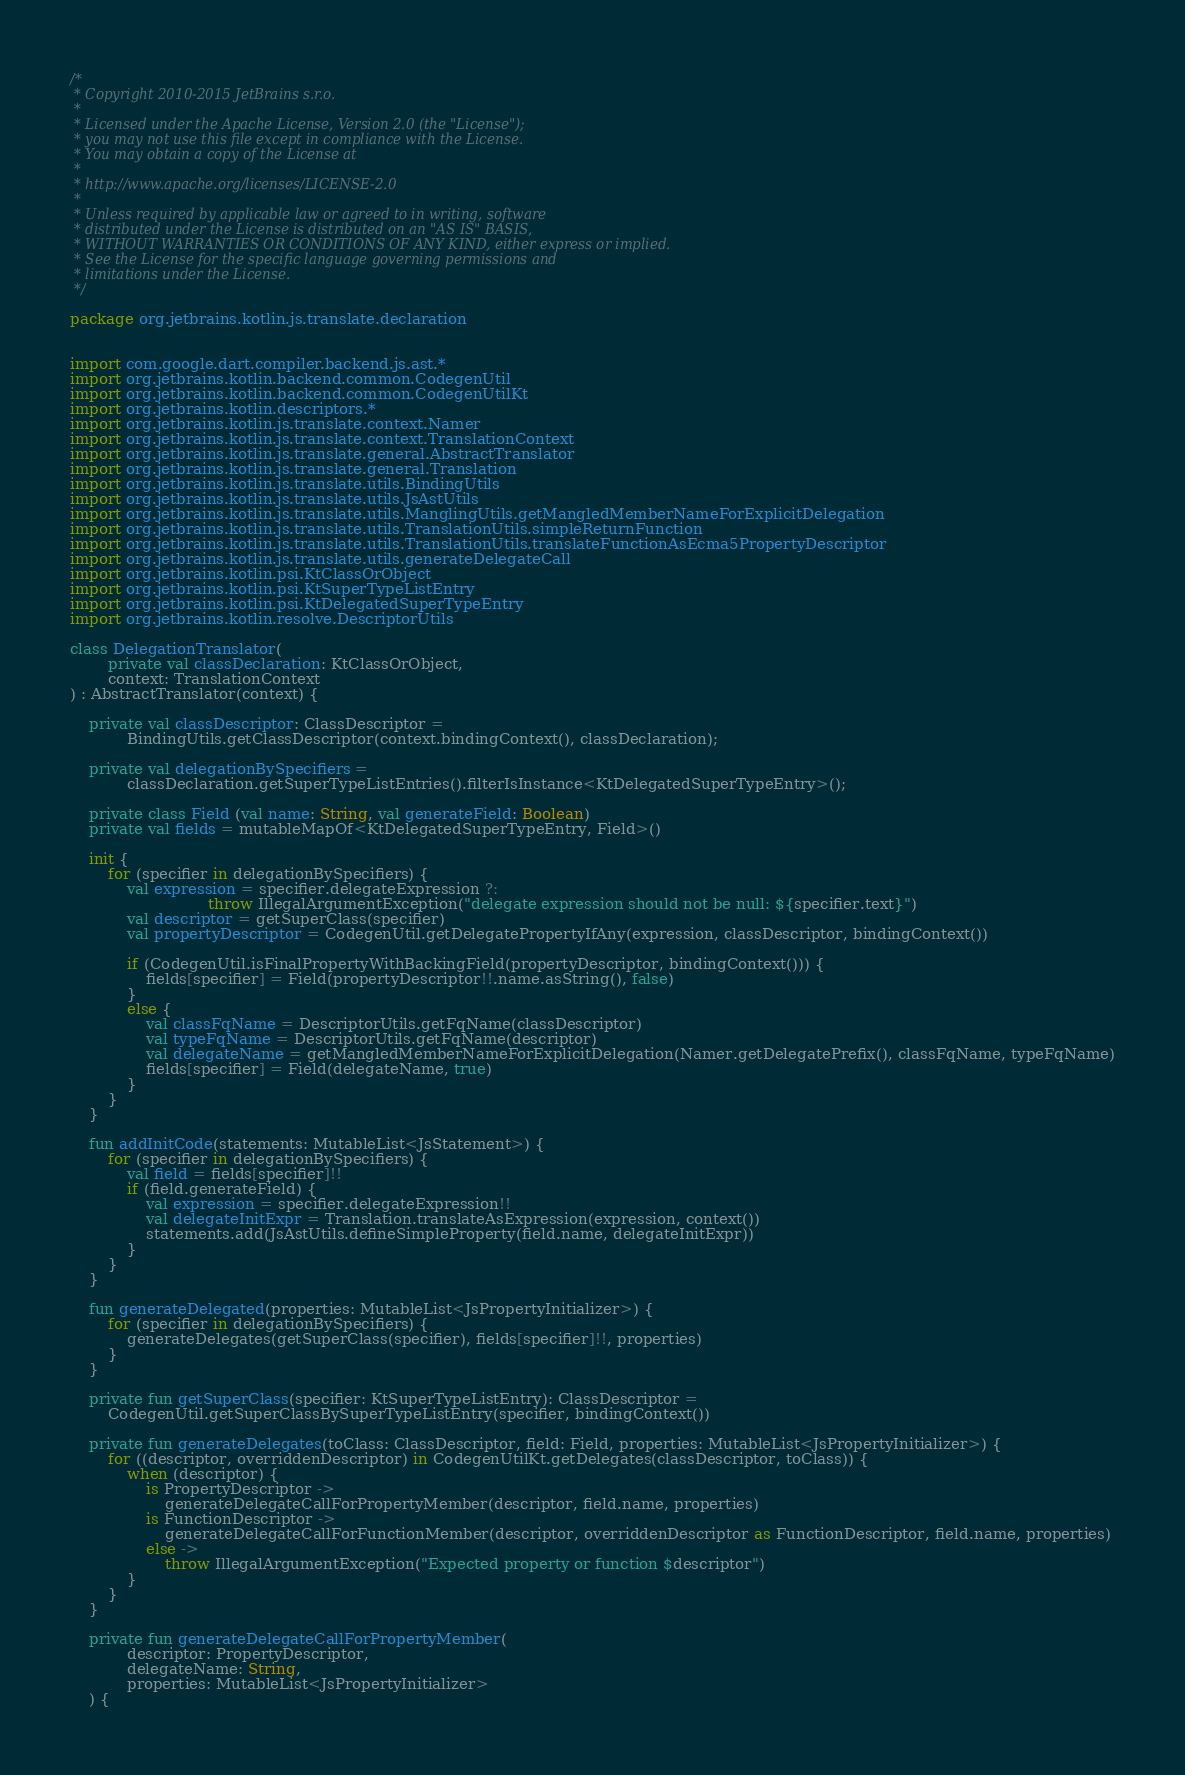<code> <loc_0><loc_0><loc_500><loc_500><_Kotlin_>/*
 * Copyright 2010-2015 JetBrains s.r.o.
 *
 * Licensed under the Apache License, Version 2.0 (the "License");
 * you may not use this file except in compliance with the License.
 * You may obtain a copy of the License at
 *
 * http://www.apache.org/licenses/LICENSE-2.0
 *
 * Unless required by applicable law or agreed to in writing, software
 * distributed under the License is distributed on an "AS IS" BASIS,
 * WITHOUT WARRANTIES OR CONDITIONS OF ANY KIND, either express or implied.
 * See the License for the specific language governing permissions and
 * limitations under the License.
 */

package org.jetbrains.kotlin.js.translate.declaration


import com.google.dart.compiler.backend.js.ast.*
import org.jetbrains.kotlin.backend.common.CodegenUtil
import org.jetbrains.kotlin.backend.common.CodegenUtilKt
import org.jetbrains.kotlin.descriptors.*
import org.jetbrains.kotlin.js.translate.context.Namer
import org.jetbrains.kotlin.js.translate.context.TranslationContext
import org.jetbrains.kotlin.js.translate.general.AbstractTranslator
import org.jetbrains.kotlin.js.translate.general.Translation
import org.jetbrains.kotlin.js.translate.utils.BindingUtils
import org.jetbrains.kotlin.js.translate.utils.JsAstUtils
import org.jetbrains.kotlin.js.translate.utils.ManglingUtils.getMangledMemberNameForExplicitDelegation
import org.jetbrains.kotlin.js.translate.utils.TranslationUtils.simpleReturnFunction
import org.jetbrains.kotlin.js.translate.utils.TranslationUtils.translateFunctionAsEcma5PropertyDescriptor
import org.jetbrains.kotlin.js.translate.utils.generateDelegateCall
import org.jetbrains.kotlin.psi.KtClassOrObject
import org.jetbrains.kotlin.psi.KtSuperTypeListEntry
import org.jetbrains.kotlin.psi.KtDelegatedSuperTypeEntry
import org.jetbrains.kotlin.resolve.DescriptorUtils

class DelegationTranslator(
        private val classDeclaration: KtClassOrObject,
        context: TranslationContext
) : AbstractTranslator(context) {

    private val classDescriptor: ClassDescriptor =
            BindingUtils.getClassDescriptor(context.bindingContext(), classDeclaration);

    private val delegationBySpecifiers =
            classDeclaration.getSuperTypeListEntries().filterIsInstance<KtDelegatedSuperTypeEntry>();

    private class Field (val name: String, val generateField: Boolean)
    private val fields = mutableMapOf<KtDelegatedSuperTypeEntry, Field>()

    init {
        for (specifier in delegationBySpecifiers) {
            val expression = specifier.delegateExpression ?:
                             throw IllegalArgumentException("delegate expression should not be null: ${specifier.text}")
            val descriptor = getSuperClass(specifier)
            val propertyDescriptor = CodegenUtil.getDelegatePropertyIfAny(expression, classDescriptor, bindingContext())

            if (CodegenUtil.isFinalPropertyWithBackingField(propertyDescriptor, bindingContext())) {
                fields[specifier] = Field(propertyDescriptor!!.name.asString(), false)
            }
            else {
                val classFqName = DescriptorUtils.getFqName(classDescriptor)
                val typeFqName = DescriptorUtils.getFqName(descriptor)
                val delegateName = getMangledMemberNameForExplicitDelegation(Namer.getDelegatePrefix(), classFqName, typeFqName)
                fields[specifier] = Field(delegateName, true)
            }
        }
    }

    fun addInitCode(statements: MutableList<JsStatement>) {
        for (specifier in delegationBySpecifiers) {
            val field = fields[specifier]!!
            if (field.generateField) {
                val expression = specifier.delegateExpression!!
                val delegateInitExpr = Translation.translateAsExpression(expression, context())
                statements.add(JsAstUtils.defineSimpleProperty(field.name, delegateInitExpr))
            }
        }
    }

    fun generateDelegated(properties: MutableList<JsPropertyInitializer>) {
        for (specifier in delegationBySpecifiers) {
            generateDelegates(getSuperClass(specifier), fields[specifier]!!, properties)
        }
    }

    private fun getSuperClass(specifier: KtSuperTypeListEntry): ClassDescriptor =
        CodegenUtil.getSuperClassBySuperTypeListEntry(specifier, bindingContext())

    private fun generateDelegates(toClass: ClassDescriptor, field: Field, properties: MutableList<JsPropertyInitializer>) {
        for ((descriptor, overriddenDescriptor) in CodegenUtilKt.getDelegates(classDescriptor, toClass)) {
            when (descriptor) {
                is PropertyDescriptor ->
                    generateDelegateCallForPropertyMember(descriptor, field.name, properties)
                is FunctionDescriptor ->
                    generateDelegateCallForFunctionMember(descriptor, overriddenDescriptor as FunctionDescriptor, field.name, properties)
                else ->
                    throw IllegalArgumentException("Expected property or function $descriptor")
            }
        }
    }

    private fun generateDelegateCallForPropertyMember(
            descriptor: PropertyDescriptor,
            delegateName: String,
            properties: MutableList<JsPropertyInitializer>
    ) {</code> 